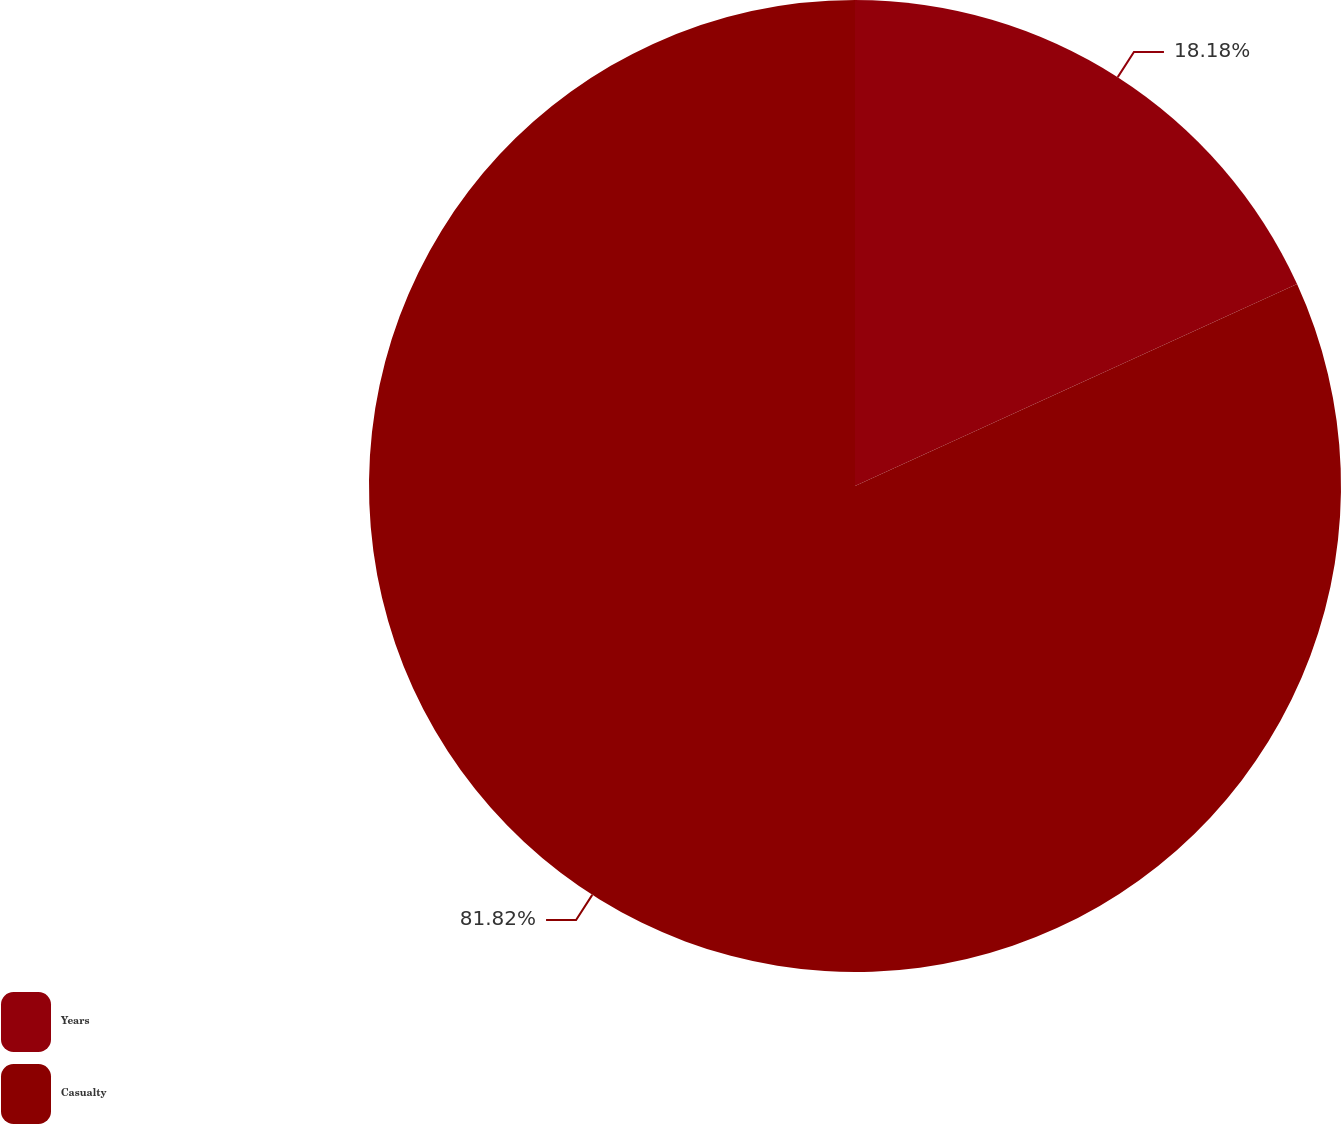Convert chart to OTSL. <chart><loc_0><loc_0><loc_500><loc_500><pie_chart><fcel>Years<fcel>Casualty<nl><fcel>18.18%<fcel>81.82%<nl></chart> 